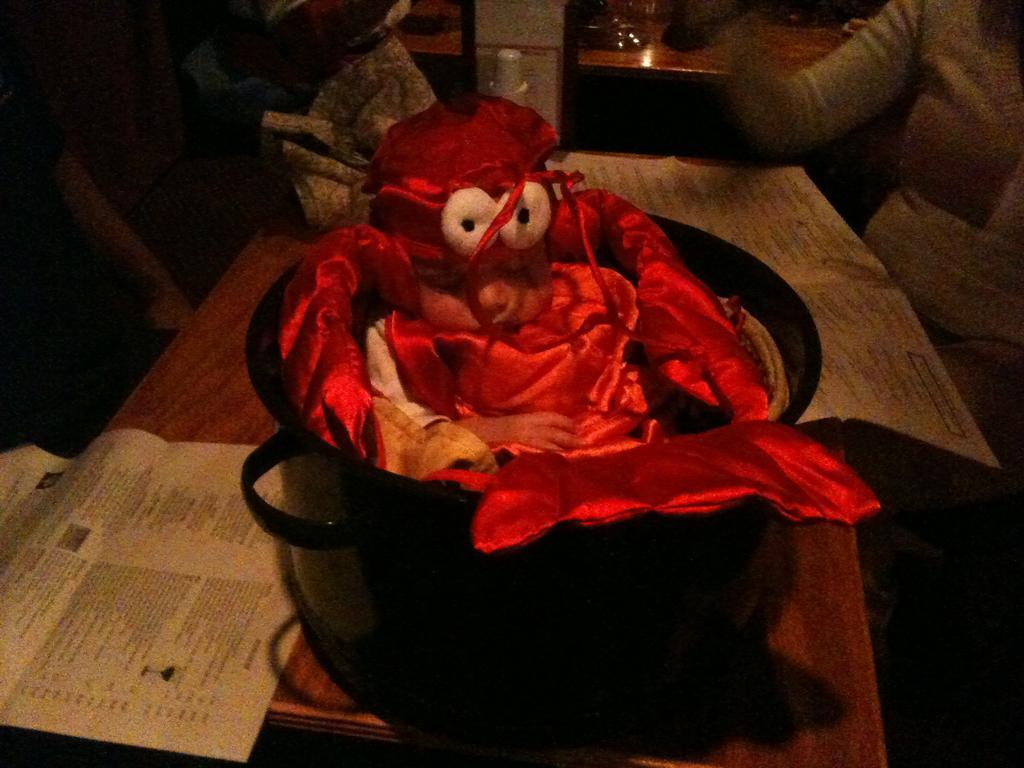Please provide a concise description of this image. In this image we can see there is a toy in the bowl, which is placed on the table and there are papers and some other objects on it. In front of the table there is another person. 